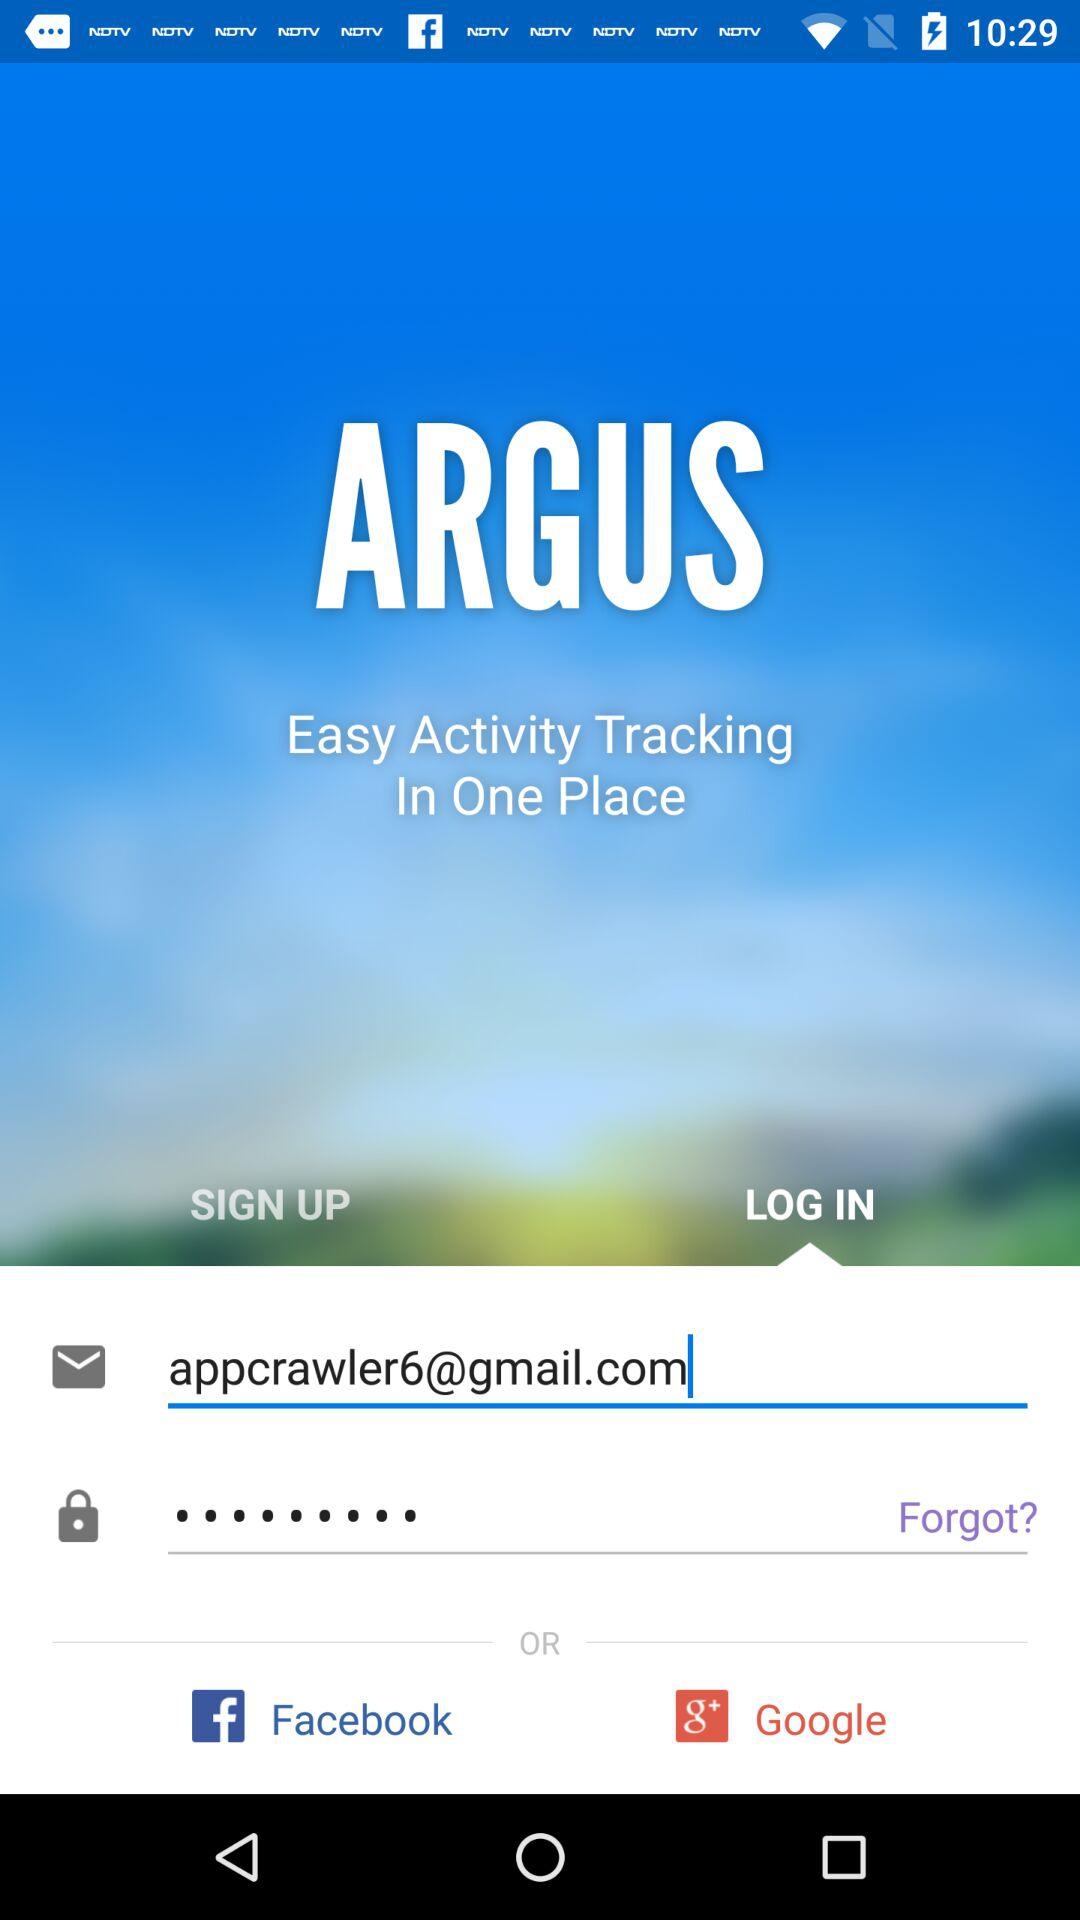What is the email address? The email address is appcrawler6@gmail.com. 